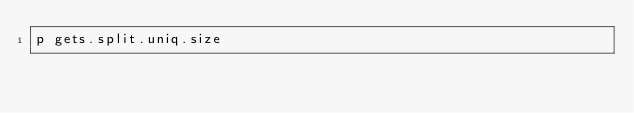<code> <loc_0><loc_0><loc_500><loc_500><_Ruby_>p gets.split.uniq.size</code> 